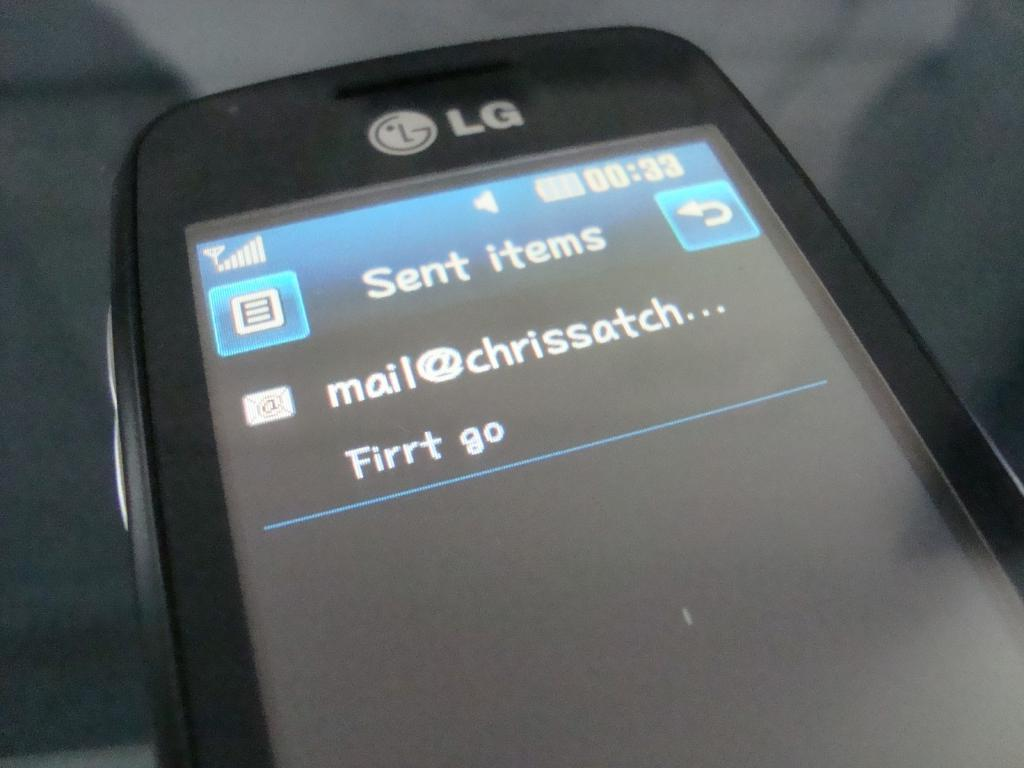<image>
Write a terse but informative summary of the picture. An LG phone sits on its back with a sent items screen open with an email that says Firrt go. 